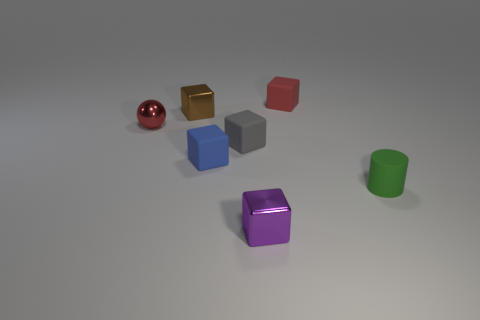Subtract all gray cubes. How many cubes are left? 4 Subtract all gray rubber blocks. How many blocks are left? 4 Subtract 2 cubes. How many cubes are left? 3 Add 1 large cyan metal blocks. How many objects exist? 8 Subtract all purple cubes. Subtract all cyan balls. How many cubes are left? 4 Subtract all cylinders. How many objects are left? 6 Add 6 small brown cubes. How many small brown cubes are left? 7 Add 2 big gray metallic objects. How many big gray metallic objects exist? 2 Subtract 0 brown cylinders. How many objects are left? 7 Subtract all tiny brown metallic things. Subtract all tiny brown cubes. How many objects are left? 5 